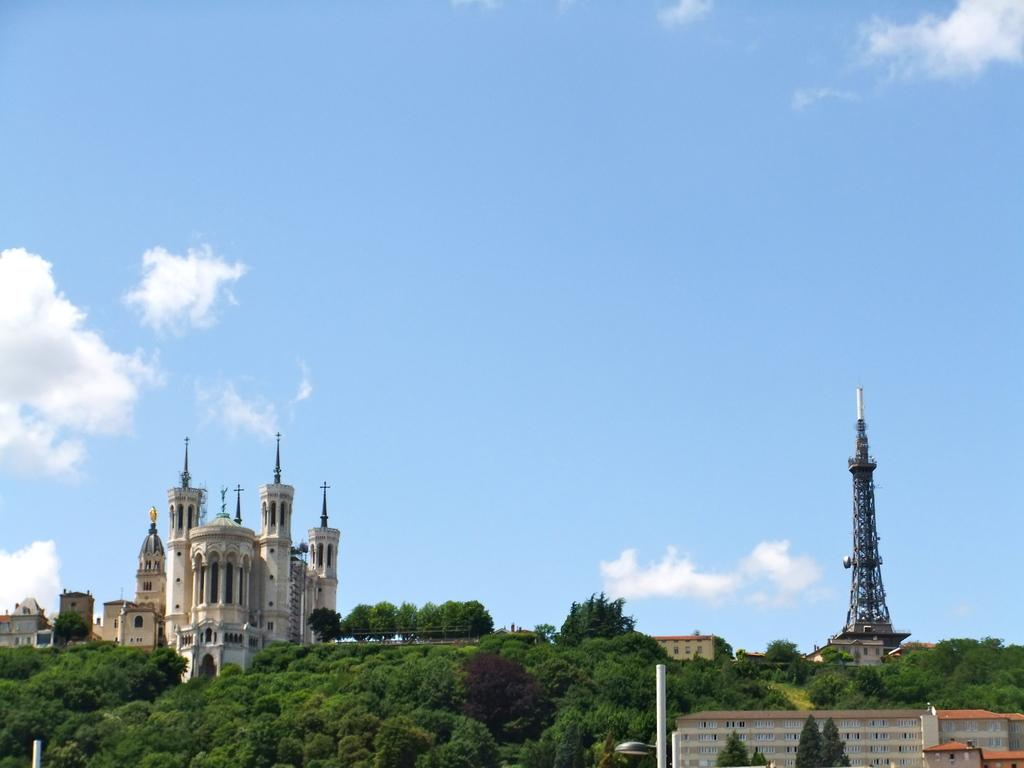What type of natural elements can be seen in the image? There are trees in the image. What type of man-made structures are present in the image? There are buildings and a tower in the image. What can be seen in the sky in the image? There are clouds visible in the image. What type of soup is being served in the image? There is no soup present in the image. What type of vessel is used to transport the people in the image? There is no vessel or transportation depicted in the image. 